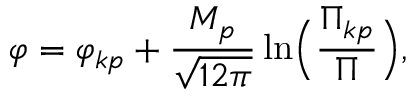<formula> <loc_0><loc_0><loc_500><loc_500>\varphi = { \varphi _ { k p } } + \frac { M _ { p } } { \sqrt { 1 2 \pi } } \ln \left ( \frac { { \Pi } _ { k p } } { \Pi } \right ) ,</formula> 